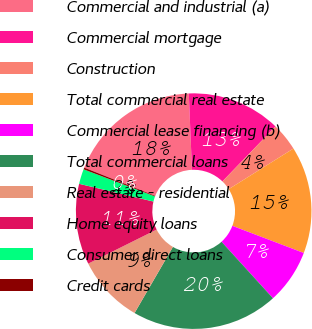<chart> <loc_0><loc_0><loc_500><loc_500><pie_chart><fcel>Commercial and industrial (a)<fcel>Commercial mortgage<fcel>Construction<fcel>Total commercial real estate<fcel>Commercial lease financing (b)<fcel>Total commercial loans<fcel>Real estate - residential<fcel>Home equity loans<fcel>Consumer direct loans<fcel>Credit cards<nl><fcel>18.32%<fcel>12.89%<fcel>3.85%<fcel>14.7%<fcel>7.47%<fcel>20.12%<fcel>9.28%<fcel>11.08%<fcel>2.05%<fcel>0.24%<nl></chart> 